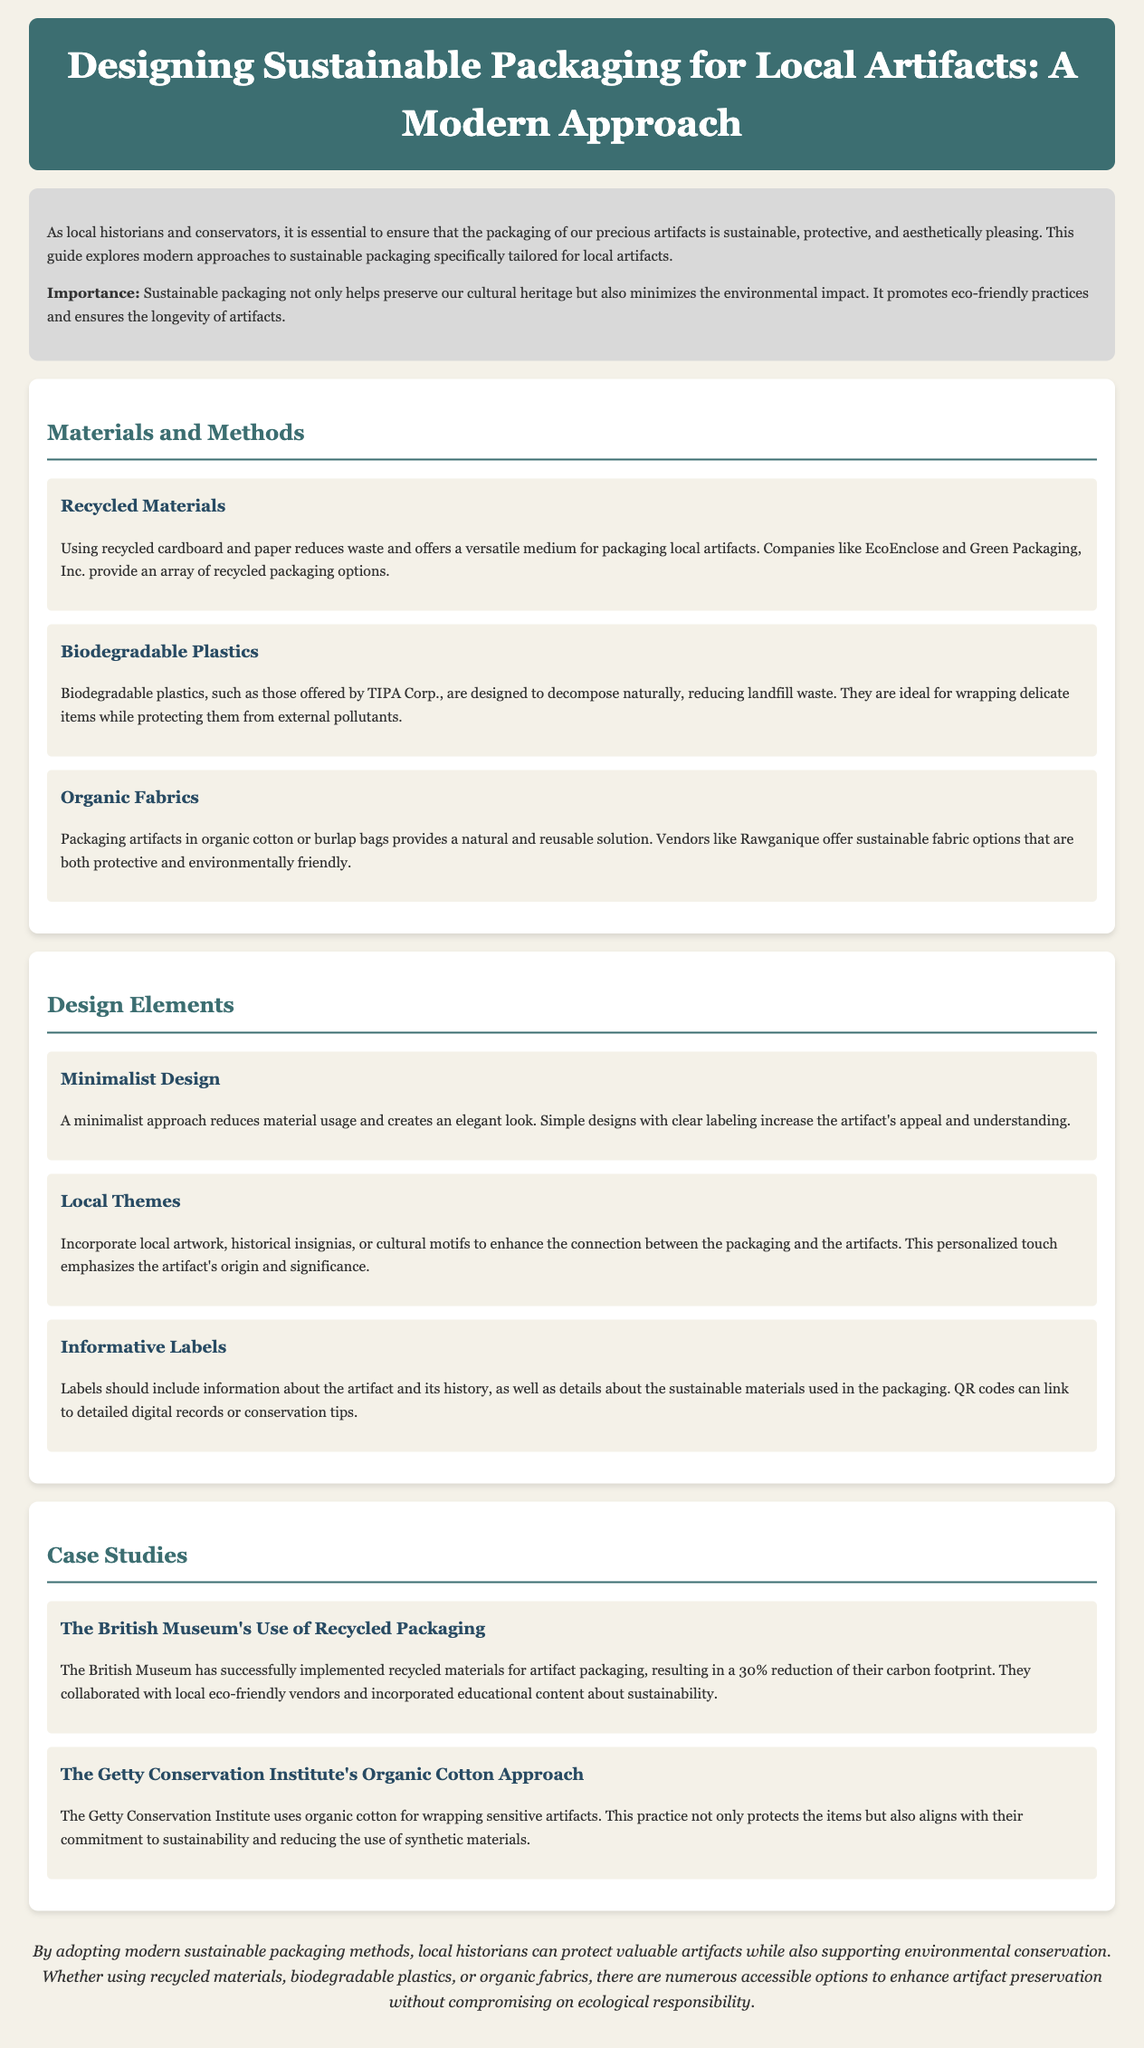What is the title of the document? The title of the document is the prominent heading that describes the content, which is "Designing Sustainable Packaging for Local Artifacts: A Modern Approach."
Answer: Designing Sustainable Packaging for Local Artifacts: A Modern Approach What is one of the materials mentioned for sustainable packaging? The document lists several materials for sustainable packaging, one of which is "recycled cardboard."
Answer: recycled cardboard How much did the British Museum reduce its carbon footprint by implementing recycled materials? The document states that the British Museum achieved a "30% reduction" in their carbon footprint.
Answer: 30% What type of fabric does the Getty Conservation Institute use? The document mentions that the Getty Conservation Institute uses "organic cotton" for wrapping sensitive artifacts.
Answer: organic cotton What is the main benefit of sustainable packaging mentioned in the introduction? The introduction highlights that sustainable packaging helps in "minimizing the environmental impact."
Answer: minimizing the environmental impact What design approach reduces material usage and creates an elegant look? The minimalist design approach is described as reducing material usage and creating an elegant look.
Answer: Minimalist Design What role do informative labels play in the packaging design? Informative labels are described as including information about the artifact and its history, which enhances understanding.
Answer: enhancing understanding What type of packaging solution does Rawganique offer? The document states that Rawganique offers "sustainable fabric options" for packaging artifacts.
Answer: sustainable fabric options 